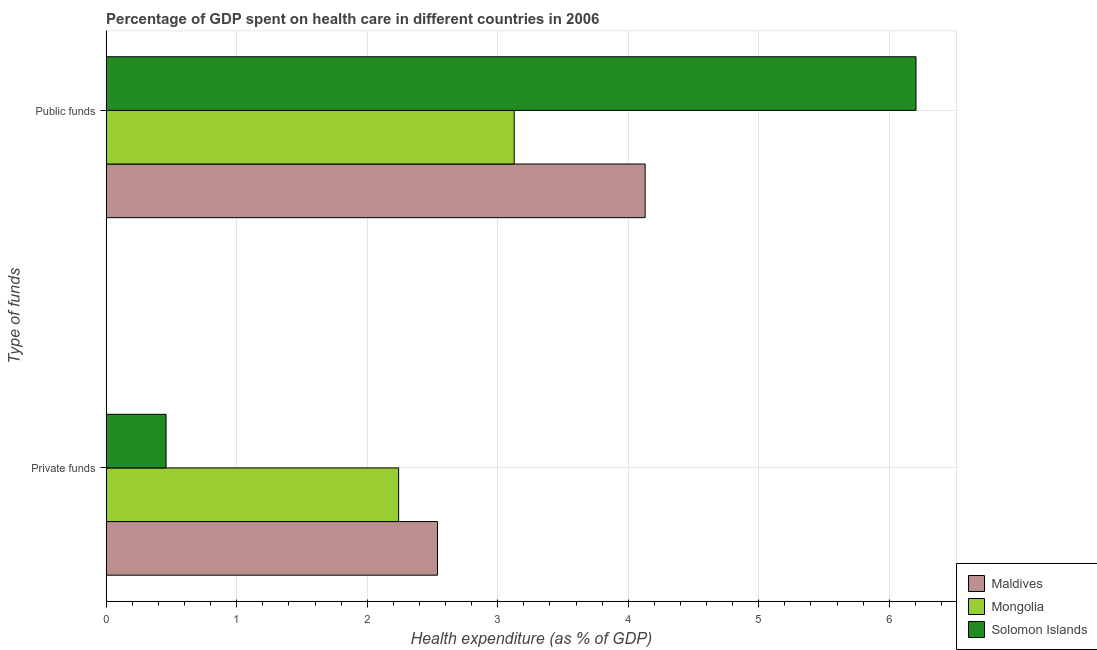How many different coloured bars are there?
Offer a very short reply. 3. Are the number of bars per tick equal to the number of legend labels?
Provide a short and direct response. Yes. How many bars are there on the 2nd tick from the top?
Ensure brevity in your answer.  3. What is the label of the 1st group of bars from the top?
Provide a short and direct response. Public funds. What is the amount of private funds spent in healthcare in Mongolia?
Your response must be concise. 2.24. Across all countries, what is the maximum amount of private funds spent in healthcare?
Your answer should be very brief. 2.54. Across all countries, what is the minimum amount of private funds spent in healthcare?
Your answer should be compact. 0.46. In which country was the amount of public funds spent in healthcare maximum?
Offer a very short reply. Solomon Islands. In which country was the amount of private funds spent in healthcare minimum?
Make the answer very short. Solomon Islands. What is the total amount of public funds spent in healthcare in the graph?
Keep it short and to the point. 13.46. What is the difference between the amount of public funds spent in healthcare in Mongolia and that in Solomon Islands?
Make the answer very short. -3.08. What is the difference between the amount of private funds spent in healthcare in Maldives and the amount of public funds spent in healthcare in Solomon Islands?
Offer a very short reply. -3.67. What is the average amount of private funds spent in healthcare per country?
Give a very brief answer. 1.75. What is the difference between the amount of private funds spent in healthcare and amount of public funds spent in healthcare in Mongolia?
Offer a terse response. -0.89. What is the ratio of the amount of public funds spent in healthcare in Mongolia to that in Solomon Islands?
Offer a terse response. 0.5. What does the 1st bar from the top in Private funds represents?
Offer a terse response. Solomon Islands. What does the 3rd bar from the bottom in Private funds represents?
Provide a short and direct response. Solomon Islands. How many bars are there?
Offer a terse response. 6. Are all the bars in the graph horizontal?
Ensure brevity in your answer.  Yes. How many countries are there in the graph?
Your response must be concise. 3. Does the graph contain any zero values?
Provide a succinct answer. No. How are the legend labels stacked?
Your answer should be very brief. Vertical. What is the title of the graph?
Keep it short and to the point. Percentage of GDP spent on health care in different countries in 2006. Does "Cabo Verde" appear as one of the legend labels in the graph?
Your answer should be compact. No. What is the label or title of the X-axis?
Your answer should be very brief. Health expenditure (as % of GDP). What is the label or title of the Y-axis?
Offer a terse response. Type of funds. What is the Health expenditure (as % of GDP) in Maldives in Private funds?
Ensure brevity in your answer.  2.54. What is the Health expenditure (as % of GDP) in Mongolia in Private funds?
Provide a short and direct response. 2.24. What is the Health expenditure (as % of GDP) of Solomon Islands in Private funds?
Keep it short and to the point. 0.46. What is the Health expenditure (as % of GDP) in Maldives in Public funds?
Offer a terse response. 4.13. What is the Health expenditure (as % of GDP) in Mongolia in Public funds?
Your response must be concise. 3.13. What is the Health expenditure (as % of GDP) in Solomon Islands in Public funds?
Provide a succinct answer. 6.21. Across all Type of funds, what is the maximum Health expenditure (as % of GDP) in Maldives?
Provide a succinct answer. 4.13. Across all Type of funds, what is the maximum Health expenditure (as % of GDP) of Mongolia?
Offer a very short reply. 3.13. Across all Type of funds, what is the maximum Health expenditure (as % of GDP) in Solomon Islands?
Your answer should be compact. 6.21. Across all Type of funds, what is the minimum Health expenditure (as % of GDP) of Maldives?
Offer a very short reply. 2.54. Across all Type of funds, what is the minimum Health expenditure (as % of GDP) in Mongolia?
Provide a short and direct response. 2.24. Across all Type of funds, what is the minimum Health expenditure (as % of GDP) in Solomon Islands?
Your answer should be compact. 0.46. What is the total Health expenditure (as % of GDP) in Maldives in the graph?
Make the answer very short. 6.67. What is the total Health expenditure (as % of GDP) in Mongolia in the graph?
Provide a succinct answer. 5.37. What is the total Health expenditure (as % of GDP) of Solomon Islands in the graph?
Ensure brevity in your answer.  6.66. What is the difference between the Health expenditure (as % of GDP) of Maldives in Private funds and that in Public funds?
Give a very brief answer. -1.59. What is the difference between the Health expenditure (as % of GDP) in Mongolia in Private funds and that in Public funds?
Provide a succinct answer. -0.89. What is the difference between the Health expenditure (as % of GDP) of Solomon Islands in Private funds and that in Public funds?
Your response must be concise. -5.75. What is the difference between the Health expenditure (as % of GDP) of Maldives in Private funds and the Health expenditure (as % of GDP) of Mongolia in Public funds?
Provide a succinct answer. -0.59. What is the difference between the Health expenditure (as % of GDP) of Maldives in Private funds and the Health expenditure (as % of GDP) of Solomon Islands in Public funds?
Your answer should be compact. -3.67. What is the difference between the Health expenditure (as % of GDP) in Mongolia in Private funds and the Health expenditure (as % of GDP) in Solomon Islands in Public funds?
Keep it short and to the point. -3.96. What is the average Health expenditure (as % of GDP) of Maldives per Type of funds?
Provide a succinct answer. 3.33. What is the average Health expenditure (as % of GDP) in Mongolia per Type of funds?
Your answer should be very brief. 2.68. What is the average Health expenditure (as % of GDP) in Solomon Islands per Type of funds?
Your response must be concise. 3.33. What is the difference between the Health expenditure (as % of GDP) in Maldives and Health expenditure (as % of GDP) in Mongolia in Private funds?
Provide a short and direct response. 0.3. What is the difference between the Health expenditure (as % of GDP) of Maldives and Health expenditure (as % of GDP) of Solomon Islands in Private funds?
Offer a terse response. 2.08. What is the difference between the Health expenditure (as % of GDP) in Mongolia and Health expenditure (as % of GDP) in Solomon Islands in Private funds?
Ensure brevity in your answer.  1.78. What is the difference between the Health expenditure (as % of GDP) in Maldives and Health expenditure (as % of GDP) in Solomon Islands in Public funds?
Ensure brevity in your answer.  -2.08. What is the difference between the Health expenditure (as % of GDP) in Mongolia and Health expenditure (as % of GDP) in Solomon Islands in Public funds?
Your answer should be compact. -3.08. What is the ratio of the Health expenditure (as % of GDP) in Maldives in Private funds to that in Public funds?
Your answer should be compact. 0.61. What is the ratio of the Health expenditure (as % of GDP) of Mongolia in Private funds to that in Public funds?
Offer a terse response. 0.72. What is the ratio of the Health expenditure (as % of GDP) in Solomon Islands in Private funds to that in Public funds?
Offer a very short reply. 0.07. What is the difference between the highest and the second highest Health expenditure (as % of GDP) in Maldives?
Provide a succinct answer. 1.59. What is the difference between the highest and the second highest Health expenditure (as % of GDP) of Mongolia?
Ensure brevity in your answer.  0.89. What is the difference between the highest and the second highest Health expenditure (as % of GDP) in Solomon Islands?
Offer a terse response. 5.75. What is the difference between the highest and the lowest Health expenditure (as % of GDP) of Maldives?
Give a very brief answer. 1.59. What is the difference between the highest and the lowest Health expenditure (as % of GDP) in Mongolia?
Offer a very short reply. 0.89. What is the difference between the highest and the lowest Health expenditure (as % of GDP) of Solomon Islands?
Offer a terse response. 5.75. 